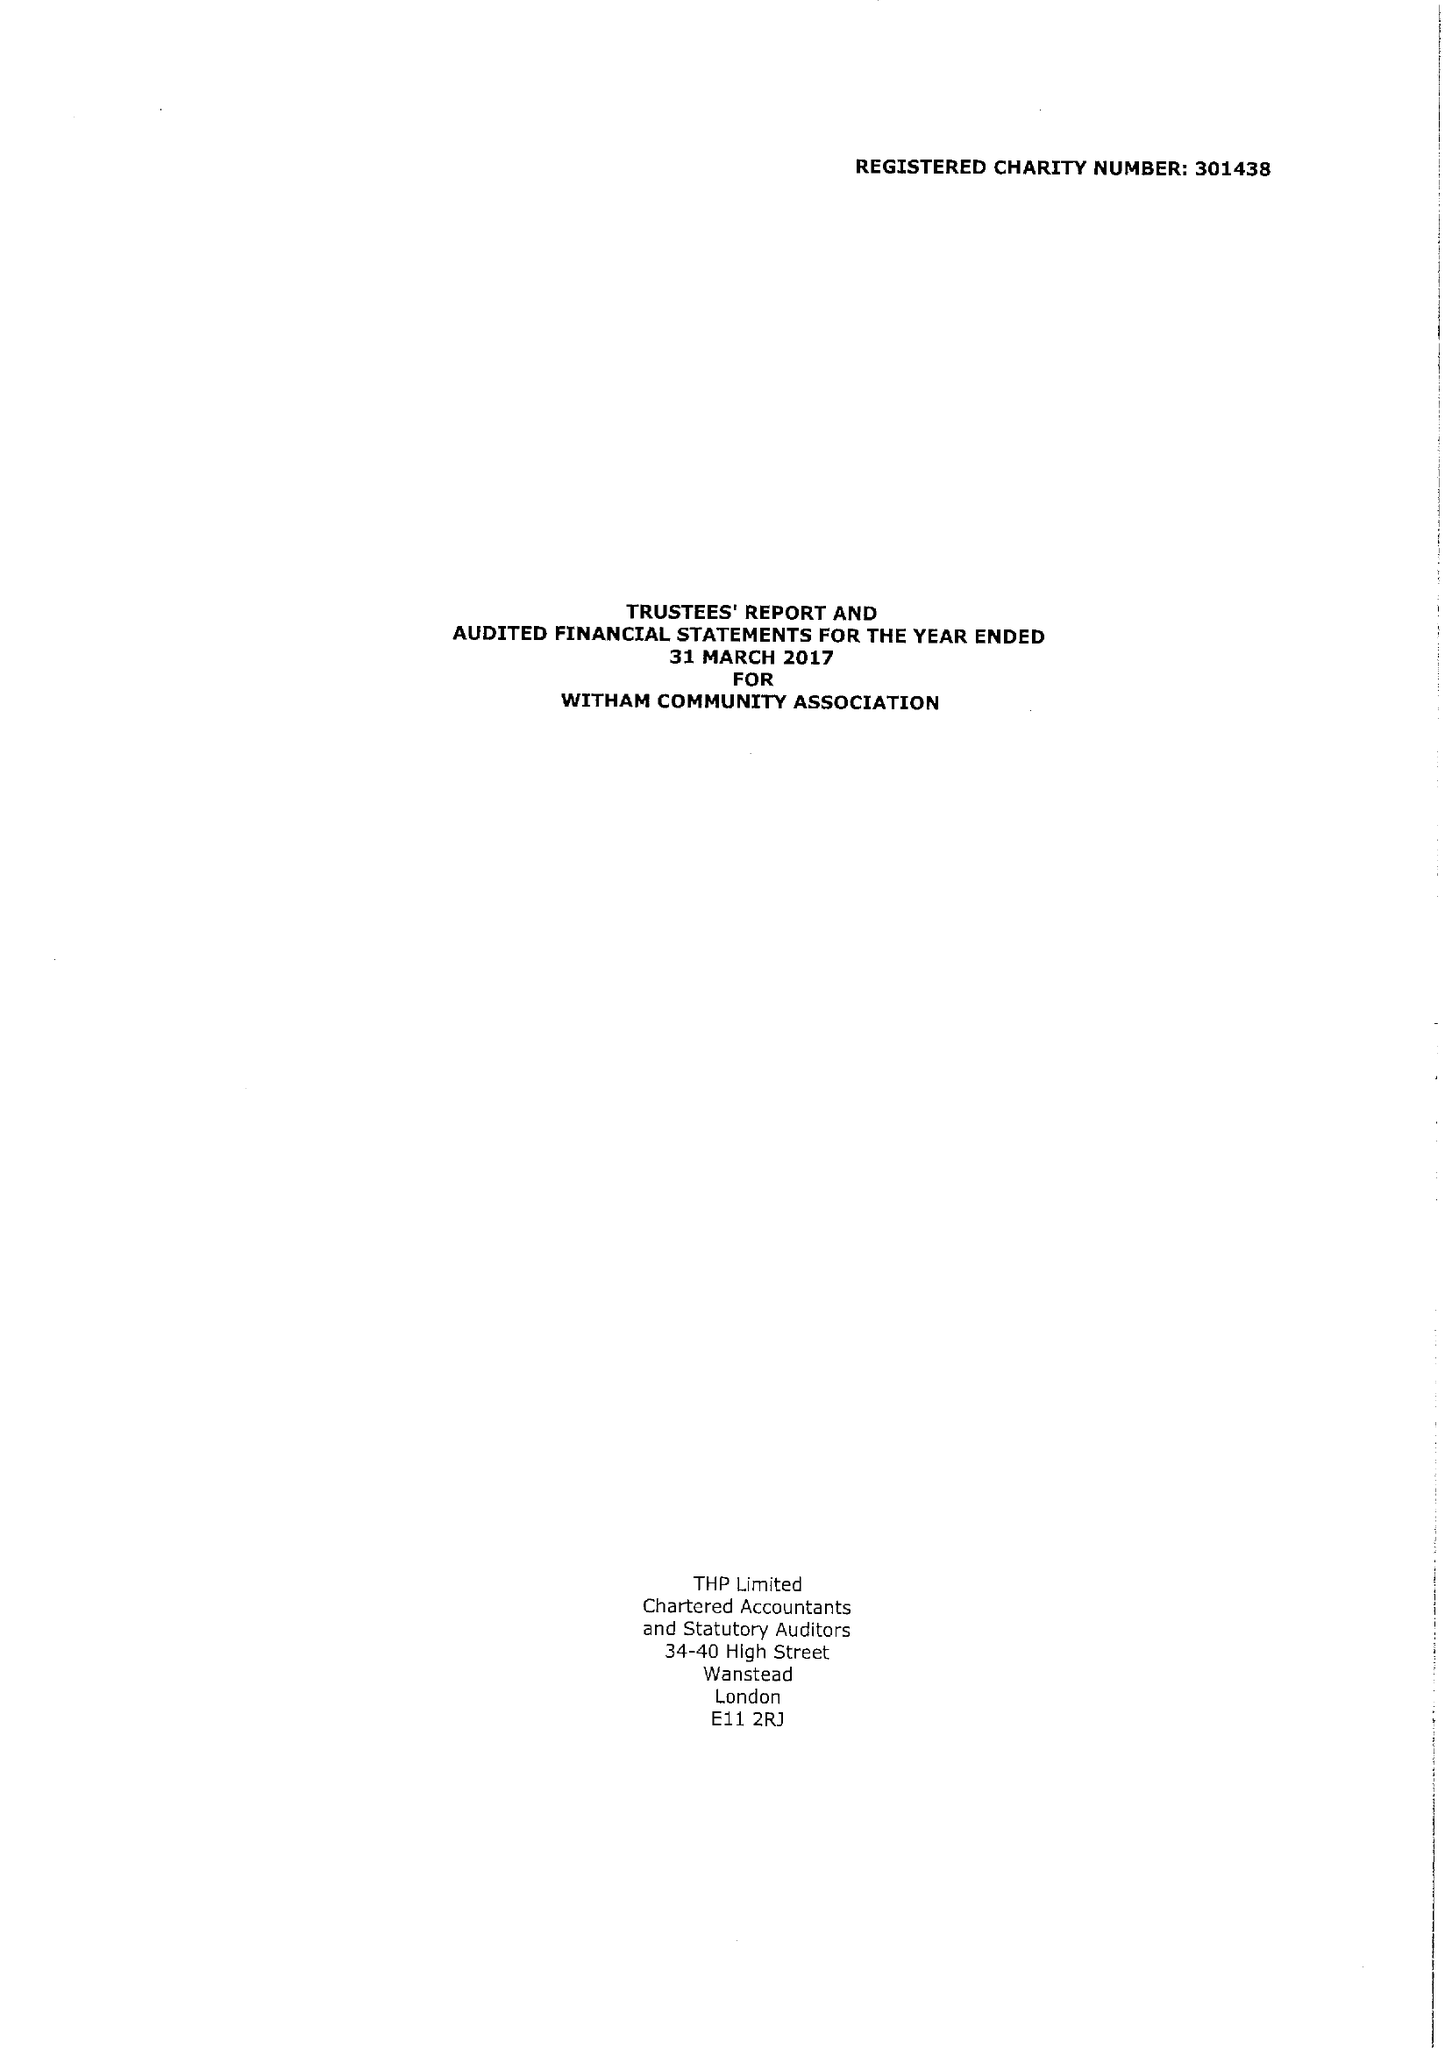What is the value for the report_date?
Answer the question using a single word or phrase. 2017-03-31 